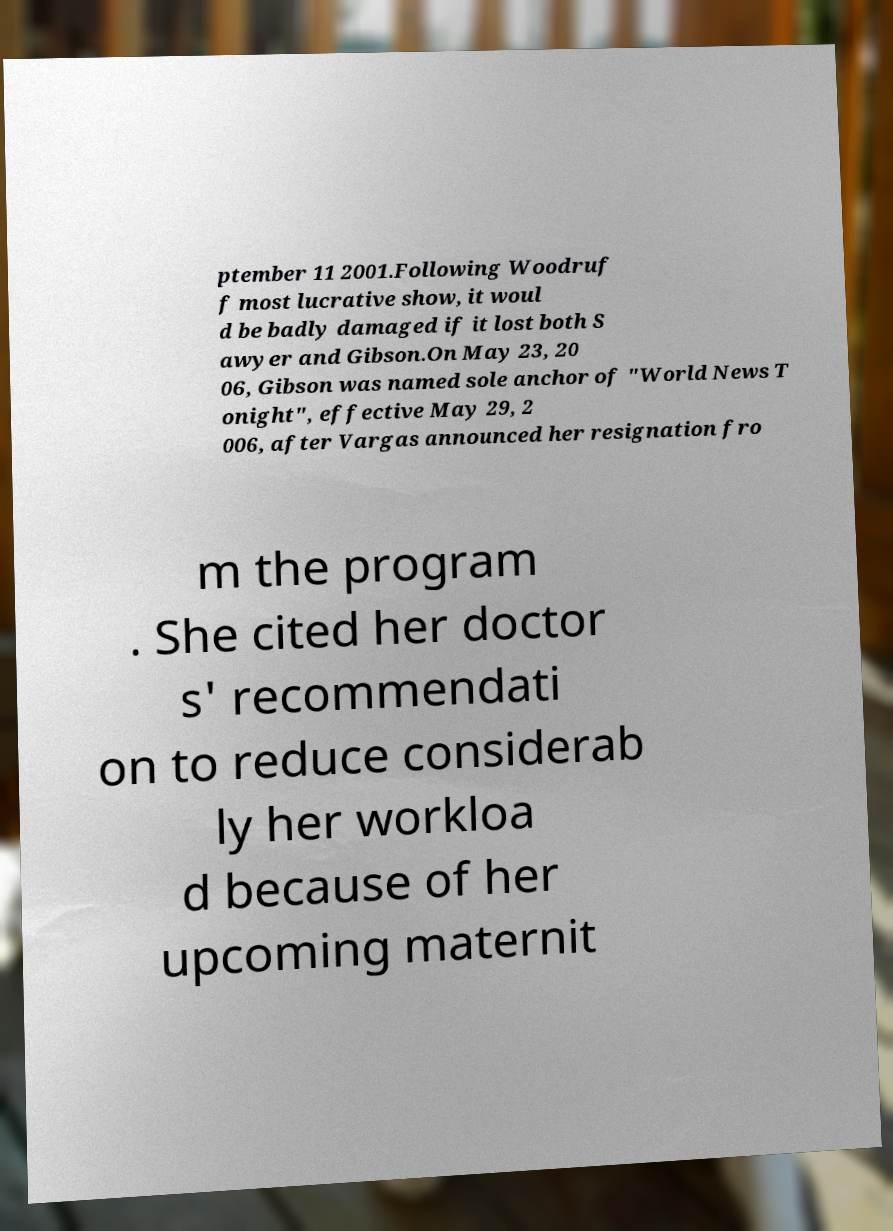Could you extract and type out the text from this image? ptember 11 2001.Following Woodruf f most lucrative show, it woul d be badly damaged if it lost both S awyer and Gibson.On May 23, 20 06, Gibson was named sole anchor of "World News T onight", effective May 29, 2 006, after Vargas announced her resignation fro m the program . She cited her doctor s' recommendati on to reduce considerab ly her workloa d because of her upcoming maternit 